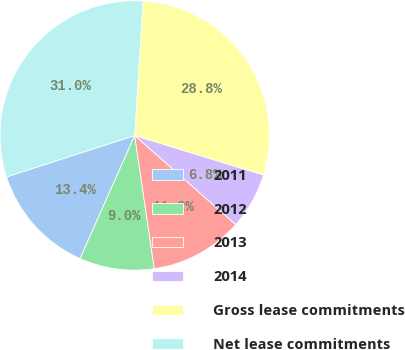<chart> <loc_0><loc_0><loc_500><loc_500><pie_chart><fcel>2011<fcel>2012<fcel>2013<fcel>2014<fcel>Gross lease commitments<fcel>Net lease commitments<nl><fcel>13.37%<fcel>8.97%<fcel>11.17%<fcel>6.77%<fcel>28.76%<fcel>30.96%<nl></chart> 